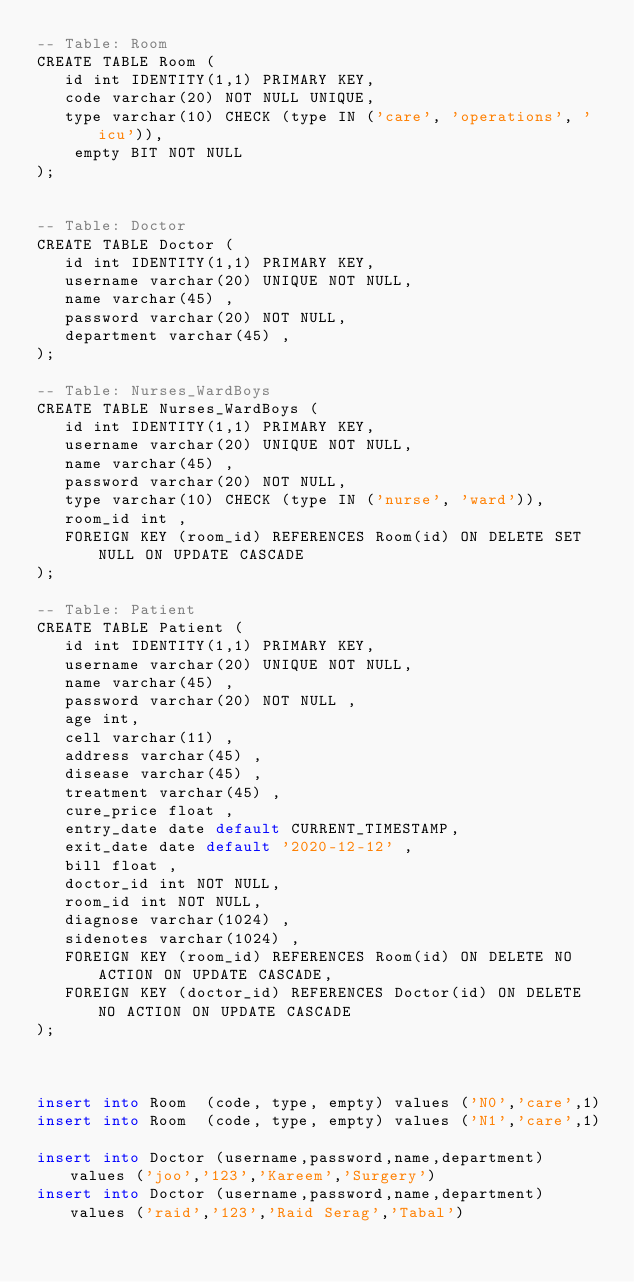Convert code to text. <code><loc_0><loc_0><loc_500><loc_500><_SQL_>-- Table: Room
CREATE TABLE Room (
   id int IDENTITY(1,1) PRIMARY KEY, 
   code varchar(20) NOT NULL UNIQUE,
   type varchar(10) CHECK (type IN ('care', 'operations', 'icu')),
    empty BIT NOT NULL
);


-- Table: Doctor
CREATE TABLE Doctor (
   id int IDENTITY(1,1) PRIMARY KEY,
   username varchar(20) UNIQUE NOT NULL,
   name varchar(45) ,
   password varchar(20) NOT NULL,
   department varchar(45) ,   
);

-- Table: Nurses_WardBoys
CREATE TABLE Nurses_WardBoys (
   id int IDENTITY(1,1) PRIMARY KEY,
   username varchar(20) UNIQUE NOT NULL,
   name varchar(45) ,
   password varchar(20) NOT NULL,
   type varchar(10) CHECK (type IN ('nurse', 'ward')),
   room_id int ,
   FOREIGN KEY (room_id) REFERENCES Room(id) ON DELETE SET NULL ON UPDATE CASCADE   
);

-- Table: Patient
CREATE TABLE Patient (
   id int IDENTITY(1,1) PRIMARY KEY,
   username varchar(20) UNIQUE NOT NULL,
   name varchar(45) ,
   password varchar(20) NOT NULL ,
   age int,
   cell varchar(11) ,
   address varchar(45) ,
   disease varchar(45) ,
   treatment varchar(45) ,
   cure_price float ,
   entry_date date default CURRENT_TIMESTAMP,
   exit_date date default '2020-12-12' ,
   bill float ,
   doctor_id int NOT NULL,
   room_id int NOT NULL,
   diagnose varchar(1024) ,
   sidenotes varchar(1024) ,
   FOREIGN KEY (room_id) REFERENCES Room(id) ON DELETE NO ACTION ON UPDATE CASCADE,
   FOREIGN KEY (doctor_id) REFERENCES Doctor(id) ON DELETE NO ACTION ON UPDATE CASCADE
);



insert into Room  (code, type, empty) values ('N0','care',1)
insert into Room  (code, type, empty) values ('N1','care',1)

insert into Doctor (username,password,name,department) values ('joo','123','Kareem','Surgery')
insert into Doctor (username,password,name,department) values ('raid','123','Raid Serag','Tabal')</code> 